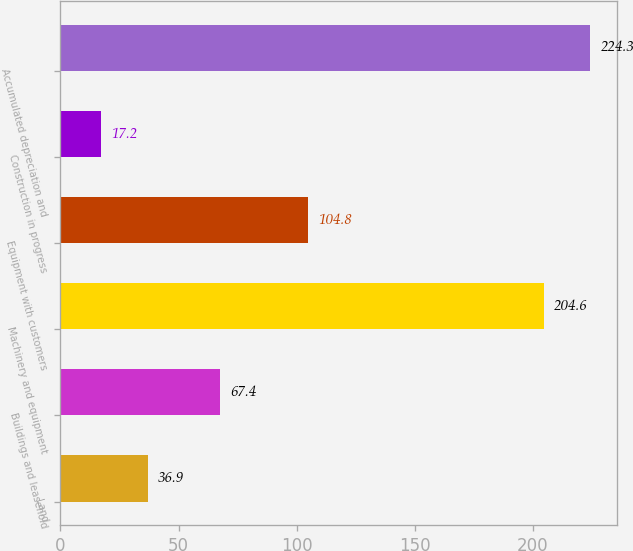<chart> <loc_0><loc_0><loc_500><loc_500><bar_chart><fcel>Land<fcel>Buildings and leasehold<fcel>Machinery and equipment<fcel>Equipment with customers<fcel>Construction in progress<fcel>Accumulated depreciation and<nl><fcel>36.9<fcel>67.4<fcel>204.6<fcel>104.8<fcel>17.2<fcel>224.3<nl></chart> 